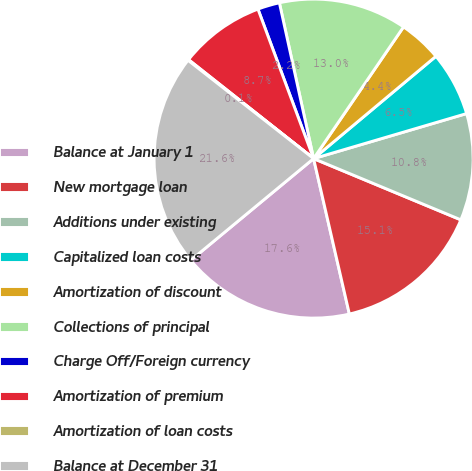Convert chart. <chart><loc_0><loc_0><loc_500><loc_500><pie_chart><fcel>Balance at January 1<fcel>New mortgage loan<fcel>Additions under existing<fcel>Capitalized loan costs<fcel>Amortization of discount<fcel>Collections of principal<fcel>Charge Off/Foreign currency<fcel>Amortization of premium<fcel>Amortization of loan costs<fcel>Balance at December 31<nl><fcel>17.6%<fcel>15.13%<fcel>10.83%<fcel>6.53%<fcel>4.38%<fcel>12.98%<fcel>2.23%<fcel>8.68%<fcel>0.08%<fcel>21.58%<nl></chart> 